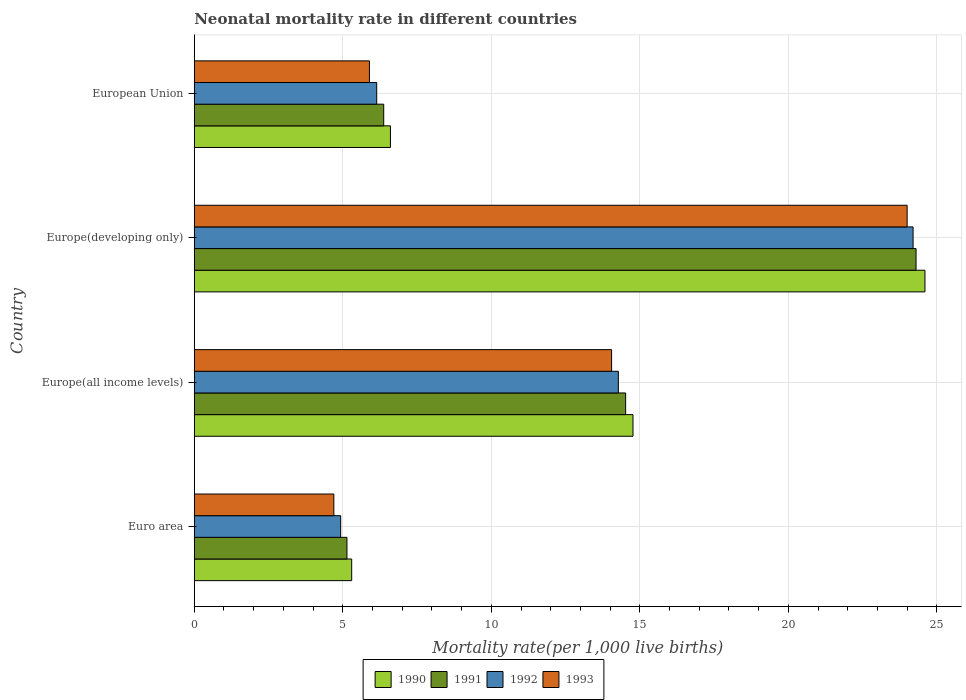Are the number of bars per tick equal to the number of legend labels?
Your response must be concise. Yes. How many bars are there on the 3rd tick from the top?
Give a very brief answer. 4. What is the label of the 3rd group of bars from the top?
Offer a very short reply. Europe(all income levels). In how many cases, is the number of bars for a given country not equal to the number of legend labels?
Offer a terse response. 0. What is the neonatal mortality rate in 1992 in Euro area?
Ensure brevity in your answer.  4.93. Across all countries, what is the maximum neonatal mortality rate in 1991?
Keep it short and to the point. 24.3. Across all countries, what is the minimum neonatal mortality rate in 1991?
Give a very brief answer. 5.14. In which country was the neonatal mortality rate in 1991 maximum?
Offer a very short reply. Europe(developing only). In which country was the neonatal mortality rate in 1991 minimum?
Keep it short and to the point. Euro area. What is the total neonatal mortality rate in 1990 in the graph?
Offer a terse response. 51.28. What is the difference between the neonatal mortality rate in 1992 in Europe(all income levels) and that in European Union?
Ensure brevity in your answer.  8.14. What is the difference between the neonatal mortality rate in 1990 in Euro area and the neonatal mortality rate in 1992 in European Union?
Your answer should be compact. -0.84. What is the average neonatal mortality rate in 1990 per country?
Make the answer very short. 12.82. What is the difference between the neonatal mortality rate in 1992 and neonatal mortality rate in 1993 in Euro area?
Keep it short and to the point. 0.23. What is the ratio of the neonatal mortality rate in 1992 in Europe(all income levels) to that in European Union?
Ensure brevity in your answer.  2.32. What is the difference between the highest and the second highest neonatal mortality rate in 1992?
Your answer should be compact. 9.92. What is the difference between the highest and the lowest neonatal mortality rate in 1991?
Give a very brief answer. 19.16. In how many countries, is the neonatal mortality rate in 1991 greater than the average neonatal mortality rate in 1991 taken over all countries?
Give a very brief answer. 2. Is it the case that in every country, the sum of the neonatal mortality rate in 1991 and neonatal mortality rate in 1992 is greater than the sum of neonatal mortality rate in 1993 and neonatal mortality rate in 1990?
Offer a terse response. No. What does the 4th bar from the top in Europe(developing only) represents?
Provide a succinct answer. 1990. How many bars are there?
Your answer should be very brief. 16. Are the values on the major ticks of X-axis written in scientific E-notation?
Your response must be concise. No. Does the graph contain grids?
Ensure brevity in your answer.  Yes. How many legend labels are there?
Make the answer very short. 4. What is the title of the graph?
Give a very brief answer. Neonatal mortality rate in different countries. Does "1965" appear as one of the legend labels in the graph?
Give a very brief answer. No. What is the label or title of the X-axis?
Keep it short and to the point. Mortality rate(per 1,0 live births). What is the Mortality rate(per 1,000 live births) in 1990 in Euro area?
Give a very brief answer. 5.3. What is the Mortality rate(per 1,000 live births) of 1991 in Euro area?
Provide a short and direct response. 5.14. What is the Mortality rate(per 1,000 live births) in 1992 in Euro area?
Your response must be concise. 4.93. What is the Mortality rate(per 1,000 live births) of 1993 in Euro area?
Offer a terse response. 4.7. What is the Mortality rate(per 1,000 live births) of 1990 in Europe(all income levels)?
Offer a terse response. 14.77. What is the Mortality rate(per 1,000 live births) of 1991 in Europe(all income levels)?
Offer a very short reply. 14.52. What is the Mortality rate(per 1,000 live births) in 1992 in Europe(all income levels)?
Ensure brevity in your answer.  14.28. What is the Mortality rate(per 1,000 live births) in 1993 in Europe(all income levels)?
Provide a succinct answer. 14.05. What is the Mortality rate(per 1,000 live births) in 1990 in Europe(developing only)?
Your answer should be very brief. 24.6. What is the Mortality rate(per 1,000 live births) of 1991 in Europe(developing only)?
Provide a short and direct response. 24.3. What is the Mortality rate(per 1,000 live births) in 1992 in Europe(developing only)?
Keep it short and to the point. 24.2. What is the Mortality rate(per 1,000 live births) in 1993 in Europe(developing only)?
Your answer should be compact. 24. What is the Mortality rate(per 1,000 live births) of 1990 in European Union?
Offer a very short reply. 6.6. What is the Mortality rate(per 1,000 live births) in 1991 in European Union?
Provide a succinct answer. 6.38. What is the Mortality rate(per 1,000 live births) of 1992 in European Union?
Provide a succinct answer. 6.14. What is the Mortality rate(per 1,000 live births) of 1993 in European Union?
Provide a short and direct response. 5.9. Across all countries, what is the maximum Mortality rate(per 1,000 live births) in 1990?
Give a very brief answer. 24.6. Across all countries, what is the maximum Mortality rate(per 1,000 live births) of 1991?
Keep it short and to the point. 24.3. Across all countries, what is the maximum Mortality rate(per 1,000 live births) in 1992?
Offer a very short reply. 24.2. Across all countries, what is the maximum Mortality rate(per 1,000 live births) of 1993?
Keep it short and to the point. 24. Across all countries, what is the minimum Mortality rate(per 1,000 live births) of 1990?
Your answer should be very brief. 5.3. Across all countries, what is the minimum Mortality rate(per 1,000 live births) of 1991?
Give a very brief answer. 5.14. Across all countries, what is the minimum Mortality rate(per 1,000 live births) of 1992?
Provide a succinct answer. 4.93. Across all countries, what is the minimum Mortality rate(per 1,000 live births) in 1993?
Make the answer very short. 4.7. What is the total Mortality rate(per 1,000 live births) of 1990 in the graph?
Offer a terse response. 51.28. What is the total Mortality rate(per 1,000 live births) of 1991 in the graph?
Keep it short and to the point. 50.34. What is the total Mortality rate(per 1,000 live births) in 1992 in the graph?
Offer a terse response. 49.55. What is the total Mortality rate(per 1,000 live births) in 1993 in the graph?
Keep it short and to the point. 48.65. What is the difference between the Mortality rate(per 1,000 live births) of 1990 in Euro area and that in Europe(all income levels)?
Offer a terse response. -9.47. What is the difference between the Mortality rate(per 1,000 live births) in 1991 in Euro area and that in Europe(all income levels)?
Give a very brief answer. -9.38. What is the difference between the Mortality rate(per 1,000 live births) of 1992 in Euro area and that in Europe(all income levels)?
Give a very brief answer. -9.35. What is the difference between the Mortality rate(per 1,000 live births) of 1993 in Euro area and that in Europe(all income levels)?
Your response must be concise. -9.35. What is the difference between the Mortality rate(per 1,000 live births) of 1990 in Euro area and that in Europe(developing only)?
Keep it short and to the point. -19.3. What is the difference between the Mortality rate(per 1,000 live births) in 1991 in Euro area and that in Europe(developing only)?
Make the answer very short. -19.16. What is the difference between the Mortality rate(per 1,000 live births) in 1992 in Euro area and that in Europe(developing only)?
Your answer should be very brief. -19.27. What is the difference between the Mortality rate(per 1,000 live births) in 1993 in Euro area and that in Europe(developing only)?
Provide a succinct answer. -19.3. What is the difference between the Mortality rate(per 1,000 live births) in 1990 in Euro area and that in European Union?
Your answer should be very brief. -1.3. What is the difference between the Mortality rate(per 1,000 live births) of 1991 in Euro area and that in European Union?
Provide a succinct answer. -1.24. What is the difference between the Mortality rate(per 1,000 live births) of 1992 in Euro area and that in European Union?
Offer a very short reply. -1.21. What is the difference between the Mortality rate(per 1,000 live births) of 1993 in Euro area and that in European Union?
Provide a short and direct response. -1.2. What is the difference between the Mortality rate(per 1,000 live births) in 1990 in Europe(all income levels) and that in Europe(developing only)?
Your answer should be compact. -9.83. What is the difference between the Mortality rate(per 1,000 live births) in 1991 in Europe(all income levels) and that in Europe(developing only)?
Your response must be concise. -9.78. What is the difference between the Mortality rate(per 1,000 live births) in 1992 in Europe(all income levels) and that in Europe(developing only)?
Provide a succinct answer. -9.92. What is the difference between the Mortality rate(per 1,000 live births) of 1993 in Europe(all income levels) and that in Europe(developing only)?
Ensure brevity in your answer.  -9.95. What is the difference between the Mortality rate(per 1,000 live births) of 1990 in Europe(all income levels) and that in European Union?
Make the answer very short. 8.17. What is the difference between the Mortality rate(per 1,000 live births) of 1991 in Europe(all income levels) and that in European Union?
Your answer should be compact. 8.14. What is the difference between the Mortality rate(per 1,000 live births) of 1992 in Europe(all income levels) and that in European Union?
Your answer should be compact. 8.14. What is the difference between the Mortality rate(per 1,000 live births) of 1993 in Europe(all income levels) and that in European Union?
Offer a very short reply. 8.15. What is the difference between the Mortality rate(per 1,000 live births) in 1990 in Europe(developing only) and that in European Union?
Make the answer very short. 18. What is the difference between the Mortality rate(per 1,000 live births) in 1991 in Europe(developing only) and that in European Union?
Your answer should be compact. 17.92. What is the difference between the Mortality rate(per 1,000 live births) of 1992 in Europe(developing only) and that in European Union?
Keep it short and to the point. 18.06. What is the difference between the Mortality rate(per 1,000 live births) of 1993 in Europe(developing only) and that in European Union?
Offer a terse response. 18.1. What is the difference between the Mortality rate(per 1,000 live births) of 1990 in Euro area and the Mortality rate(per 1,000 live births) of 1991 in Europe(all income levels)?
Provide a short and direct response. -9.22. What is the difference between the Mortality rate(per 1,000 live births) of 1990 in Euro area and the Mortality rate(per 1,000 live births) of 1992 in Europe(all income levels)?
Give a very brief answer. -8.98. What is the difference between the Mortality rate(per 1,000 live births) in 1990 in Euro area and the Mortality rate(per 1,000 live births) in 1993 in Europe(all income levels)?
Your answer should be very brief. -8.75. What is the difference between the Mortality rate(per 1,000 live births) in 1991 in Euro area and the Mortality rate(per 1,000 live births) in 1992 in Europe(all income levels)?
Make the answer very short. -9.14. What is the difference between the Mortality rate(per 1,000 live births) in 1991 in Euro area and the Mortality rate(per 1,000 live births) in 1993 in Europe(all income levels)?
Offer a very short reply. -8.91. What is the difference between the Mortality rate(per 1,000 live births) in 1992 in Euro area and the Mortality rate(per 1,000 live births) in 1993 in Europe(all income levels)?
Keep it short and to the point. -9.12. What is the difference between the Mortality rate(per 1,000 live births) of 1990 in Euro area and the Mortality rate(per 1,000 live births) of 1991 in Europe(developing only)?
Your answer should be compact. -19. What is the difference between the Mortality rate(per 1,000 live births) in 1990 in Euro area and the Mortality rate(per 1,000 live births) in 1992 in Europe(developing only)?
Offer a very short reply. -18.9. What is the difference between the Mortality rate(per 1,000 live births) of 1990 in Euro area and the Mortality rate(per 1,000 live births) of 1993 in Europe(developing only)?
Give a very brief answer. -18.7. What is the difference between the Mortality rate(per 1,000 live births) of 1991 in Euro area and the Mortality rate(per 1,000 live births) of 1992 in Europe(developing only)?
Offer a terse response. -19.06. What is the difference between the Mortality rate(per 1,000 live births) of 1991 in Euro area and the Mortality rate(per 1,000 live births) of 1993 in Europe(developing only)?
Offer a terse response. -18.86. What is the difference between the Mortality rate(per 1,000 live births) in 1992 in Euro area and the Mortality rate(per 1,000 live births) in 1993 in Europe(developing only)?
Offer a very short reply. -19.07. What is the difference between the Mortality rate(per 1,000 live births) of 1990 in Euro area and the Mortality rate(per 1,000 live births) of 1991 in European Union?
Provide a succinct answer. -1.08. What is the difference between the Mortality rate(per 1,000 live births) of 1990 in Euro area and the Mortality rate(per 1,000 live births) of 1992 in European Union?
Your answer should be compact. -0.84. What is the difference between the Mortality rate(per 1,000 live births) of 1990 in Euro area and the Mortality rate(per 1,000 live births) of 1993 in European Union?
Provide a short and direct response. -0.6. What is the difference between the Mortality rate(per 1,000 live births) of 1991 in Euro area and the Mortality rate(per 1,000 live births) of 1992 in European Union?
Your answer should be compact. -1. What is the difference between the Mortality rate(per 1,000 live births) of 1991 in Euro area and the Mortality rate(per 1,000 live births) of 1993 in European Union?
Provide a short and direct response. -0.76. What is the difference between the Mortality rate(per 1,000 live births) in 1992 in Euro area and the Mortality rate(per 1,000 live births) in 1993 in European Union?
Your response must be concise. -0.97. What is the difference between the Mortality rate(per 1,000 live births) of 1990 in Europe(all income levels) and the Mortality rate(per 1,000 live births) of 1991 in Europe(developing only)?
Give a very brief answer. -9.53. What is the difference between the Mortality rate(per 1,000 live births) of 1990 in Europe(all income levels) and the Mortality rate(per 1,000 live births) of 1992 in Europe(developing only)?
Give a very brief answer. -9.43. What is the difference between the Mortality rate(per 1,000 live births) of 1990 in Europe(all income levels) and the Mortality rate(per 1,000 live births) of 1993 in Europe(developing only)?
Provide a short and direct response. -9.23. What is the difference between the Mortality rate(per 1,000 live births) in 1991 in Europe(all income levels) and the Mortality rate(per 1,000 live births) in 1992 in Europe(developing only)?
Provide a short and direct response. -9.68. What is the difference between the Mortality rate(per 1,000 live births) of 1991 in Europe(all income levels) and the Mortality rate(per 1,000 live births) of 1993 in Europe(developing only)?
Offer a very short reply. -9.48. What is the difference between the Mortality rate(per 1,000 live births) of 1992 in Europe(all income levels) and the Mortality rate(per 1,000 live births) of 1993 in Europe(developing only)?
Keep it short and to the point. -9.72. What is the difference between the Mortality rate(per 1,000 live births) of 1990 in Europe(all income levels) and the Mortality rate(per 1,000 live births) of 1991 in European Union?
Provide a short and direct response. 8.39. What is the difference between the Mortality rate(per 1,000 live births) in 1990 in Europe(all income levels) and the Mortality rate(per 1,000 live births) in 1992 in European Union?
Offer a very short reply. 8.63. What is the difference between the Mortality rate(per 1,000 live births) of 1990 in Europe(all income levels) and the Mortality rate(per 1,000 live births) of 1993 in European Union?
Provide a succinct answer. 8.87. What is the difference between the Mortality rate(per 1,000 live births) in 1991 in Europe(all income levels) and the Mortality rate(per 1,000 live births) in 1992 in European Union?
Ensure brevity in your answer.  8.38. What is the difference between the Mortality rate(per 1,000 live births) of 1991 in Europe(all income levels) and the Mortality rate(per 1,000 live births) of 1993 in European Union?
Your answer should be very brief. 8.63. What is the difference between the Mortality rate(per 1,000 live births) in 1992 in Europe(all income levels) and the Mortality rate(per 1,000 live births) in 1993 in European Union?
Keep it short and to the point. 8.38. What is the difference between the Mortality rate(per 1,000 live births) in 1990 in Europe(developing only) and the Mortality rate(per 1,000 live births) in 1991 in European Union?
Your response must be concise. 18.22. What is the difference between the Mortality rate(per 1,000 live births) in 1990 in Europe(developing only) and the Mortality rate(per 1,000 live births) in 1992 in European Union?
Keep it short and to the point. 18.46. What is the difference between the Mortality rate(per 1,000 live births) of 1990 in Europe(developing only) and the Mortality rate(per 1,000 live births) of 1993 in European Union?
Give a very brief answer. 18.7. What is the difference between the Mortality rate(per 1,000 live births) of 1991 in Europe(developing only) and the Mortality rate(per 1,000 live births) of 1992 in European Union?
Your answer should be compact. 18.16. What is the difference between the Mortality rate(per 1,000 live births) of 1991 in Europe(developing only) and the Mortality rate(per 1,000 live births) of 1993 in European Union?
Ensure brevity in your answer.  18.4. What is the difference between the Mortality rate(per 1,000 live births) in 1992 in Europe(developing only) and the Mortality rate(per 1,000 live births) in 1993 in European Union?
Your answer should be very brief. 18.3. What is the average Mortality rate(per 1,000 live births) in 1990 per country?
Your answer should be compact. 12.82. What is the average Mortality rate(per 1,000 live births) of 1991 per country?
Offer a very short reply. 12.59. What is the average Mortality rate(per 1,000 live births) of 1992 per country?
Give a very brief answer. 12.39. What is the average Mortality rate(per 1,000 live births) in 1993 per country?
Offer a terse response. 12.16. What is the difference between the Mortality rate(per 1,000 live births) in 1990 and Mortality rate(per 1,000 live births) in 1991 in Euro area?
Provide a succinct answer. 0.16. What is the difference between the Mortality rate(per 1,000 live births) of 1990 and Mortality rate(per 1,000 live births) of 1992 in Euro area?
Offer a very short reply. 0.37. What is the difference between the Mortality rate(per 1,000 live births) of 1990 and Mortality rate(per 1,000 live births) of 1993 in Euro area?
Your answer should be very brief. 0.6. What is the difference between the Mortality rate(per 1,000 live births) in 1991 and Mortality rate(per 1,000 live births) in 1992 in Euro area?
Make the answer very short. 0.21. What is the difference between the Mortality rate(per 1,000 live births) of 1991 and Mortality rate(per 1,000 live births) of 1993 in Euro area?
Offer a very short reply. 0.44. What is the difference between the Mortality rate(per 1,000 live births) of 1992 and Mortality rate(per 1,000 live births) of 1993 in Euro area?
Keep it short and to the point. 0.23. What is the difference between the Mortality rate(per 1,000 live births) in 1990 and Mortality rate(per 1,000 live births) in 1991 in Europe(all income levels)?
Keep it short and to the point. 0.25. What is the difference between the Mortality rate(per 1,000 live births) in 1990 and Mortality rate(per 1,000 live births) in 1992 in Europe(all income levels)?
Ensure brevity in your answer.  0.49. What is the difference between the Mortality rate(per 1,000 live births) of 1990 and Mortality rate(per 1,000 live births) of 1993 in Europe(all income levels)?
Offer a terse response. 0.72. What is the difference between the Mortality rate(per 1,000 live births) in 1991 and Mortality rate(per 1,000 live births) in 1992 in Europe(all income levels)?
Provide a short and direct response. 0.25. What is the difference between the Mortality rate(per 1,000 live births) of 1991 and Mortality rate(per 1,000 live births) of 1993 in Europe(all income levels)?
Your answer should be compact. 0.47. What is the difference between the Mortality rate(per 1,000 live births) in 1992 and Mortality rate(per 1,000 live births) in 1993 in Europe(all income levels)?
Your response must be concise. 0.23. What is the difference between the Mortality rate(per 1,000 live births) of 1990 and Mortality rate(per 1,000 live births) of 1991 in Europe(developing only)?
Your response must be concise. 0.3. What is the difference between the Mortality rate(per 1,000 live births) in 1990 and Mortality rate(per 1,000 live births) in 1993 in Europe(developing only)?
Your answer should be very brief. 0.6. What is the difference between the Mortality rate(per 1,000 live births) in 1991 and Mortality rate(per 1,000 live births) in 1992 in Europe(developing only)?
Provide a succinct answer. 0.1. What is the difference between the Mortality rate(per 1,000 live births) in 1992 and Mortality rate(per 1,000 live births) in 1993 in Europe(developing only)?
Provide a succinct answer. 0.2. What is the difference between the Mortality rate(per 1,000 live births) in 1990 and Mortality rate(per 1,000 live births) in 1991 in European Union?
Make the answer very short. 0.23. What is the difference between the Mortality rate(per 1,000 live births) in 1990 and Mortality rate(per 1,000 live births) in 1992 in European Union?
Ensure brevity in your answer.  0.46. What is the difference between the Mortality rate(per 1,000 live births) of 1990 and Mortality rate(per 1,000 live births) of 1993 in European Union?
Give a very brief answer. 0.71. What is the difference between the Mortality rate(per 1,000 live births) of 1991 and Mortality rate(per 1,000 live births) of 1992 in European Union?
Your response must be concise. 0.24. What is the difference between the Mortality rate(per 1,000 live births) of 1991 and Mortality rate(per 1,000 live births) of 1993 in European Union?
Make the answer very short. 0.48. What is the difference between the Mortality rate(per 1,000 live births) in 1992 and Mortality rate(per 1,000 live births) in 1993 in European Union?
Make the answer very short. 0.24. What is the ratio of the Mortality rate(per 1,000 live births) of 1990 in Euro area to that in Europe(all income levels)?
Your response must be concise. 0.36. What is the ratio of the Mortality rate(per 1,000 live births) of 1991 in Euro area to that in Europe(all income levels)?
Make the answer very short. 0.35. What is the ratio of the Mortality rate(per 1,000 live births) in 1992 in Euro area to that in Europe(all income levels)?
Ensure brevity in your answer.  0.35. What is the ratio of the Mortality rate(per 1,000 live births) in 1993 in Euro area to that in Europe(all income levels)?
Ensure brevity in your answer.  0.33. What is the ratio of the Mortality rate(per 1,000 live births) in 1990 in Euro area to that in Europe(developing only)?
Make the answer very short. 0.22. What is the ratio of the Mortality rate(per 1,000 live births) of 1991 in Euro area to that in Europe(developing only)?
Your answer should be compact. 0.21. What is the ratio of the Mortality rate(per 1,000 live births) of 1992 in Euro area to that in Europe(developing only)?
Offer a very short reply. 0.2. What is the ratio of the Mortality rate(per 1,000 live births) in 1993 in Euro area to that in Europe(developing only)?
Give a very brief answer. 0.2. What is the ratio of the Mortality rate(per 1,000 live births) in 1990 in Euro area to that in European Union?
Provide a succinct answer. 0.8. What is the ratio of the Mortality rate(per 1,000 live births) of 1991 in Euro area to that in European Union?
Your answer should be very brief. 0.81. What is the ratio of the Mortality rate(per 1,000 live births) in 1992 in Euro area to that in European Union?
Keep it short and to the point. 0.8. What is the ratio of the Mortality rate(per 1,000 live births) in 1993 in Euro area to that in European Union?
Your response must be concise. 0.8. What is the ratio of the Mortality rate(per 1,000 live births) in 1990 in Europe(all income levels) to that in Europe(developing only)?
Offer a terse response. 0.6. What is the ratio of the Mortality rate(per 1,000 live births) of 1991 in Europe(all income levels) to that in Europe(developing only)?
Provide a short and direct response. 0.6. What is the ratio of the Mortality rate(per 1,000 live births) in 1992 in Europe(all income levels) to that in Europe(developing only)?
Offer a terse response. 0.59. What is the ratio of the Mortality rate(per 1,000 live births) in 1993 in Europe(all income levels) to that in Europe(developing only)?
Your answer should be very brief. 0.59. What is the ratio of the Mortality rate(per 1,000 live births) in 1990 in Europe(all income levels) to that in European Union?
Keep it short and to the point. 2.24. What is the ratio of the Mortality rate(per 1,000 live births) of 1991 in Europe(all income levels) to that in European Union?
Ensure brevity in your answer.  2.28. What is the ratio of the Mortality rate(per 1,000 live births) of 1992 in Europe(all income levels) to that in European Union?
Offer a terse response. 2.32. What is the ratio of the Mortality rate(per 1,000 live births) of 1993 in Europe(all income levels) to that in European Union?
Provide a succinct answer. 2.38. What is the ratio of the Mortality rate(per 1,000 live births) in 1990 in Europe(developing only) to that in European Union?
Offer a terse response. 3.72. What is the ratio of the Mortality rate(per 1,000 live births) in 1991 in Europe(developing only) to that in European Union?
Provide a succinct answer. 3.81. What is the ratio of the Mortality rate(per 1,000 live births) in 1992 in Europe(developing only) to that in European Union?
Make the answer very short. 3.94. What is the ratio of the Mortality rate(per 1,000 live births) in 1993 in Europe(developing only) to that in European Union?
Keep it short and to the point. 4.07. What is the difference between the highest and the second highest Mortality rate(per 1,000 live births) in 1990?
Provide a short and direct response. 9.83. What is the difference between the highest and the second highest Mortality rate(per 1,000 live births) in 1991?
Give a very brief answer. 9.78. What is the difference between the highest and the second highest Mortality rate(per 1,000 live births) in 1992?
Provide a succinct answer. 9.92. What is the difference between the highest and the second highest Mortality rate(per 1,000 live births) of 1993?
Keep it short and to the point. 9.95. What is the difference between the highest and the lowest Mortality rate(per 1,000 live births) of 1990?
Provide a short and direct response. 19.3. What is the difference between the highest and the lowest Mortality rate(per 1,000 live births) in 1991?
Your answer should be very brief. 19.16. What is the difference between the highest and the lowest Mortality rate(per 1,000 live births) of 1992?
Make the answer very short. 19.27. What is the difference between the highest and the lowest Mortality rate(per 1,000 live births) in 1993?
Provide a short and direct response. 19.3. 